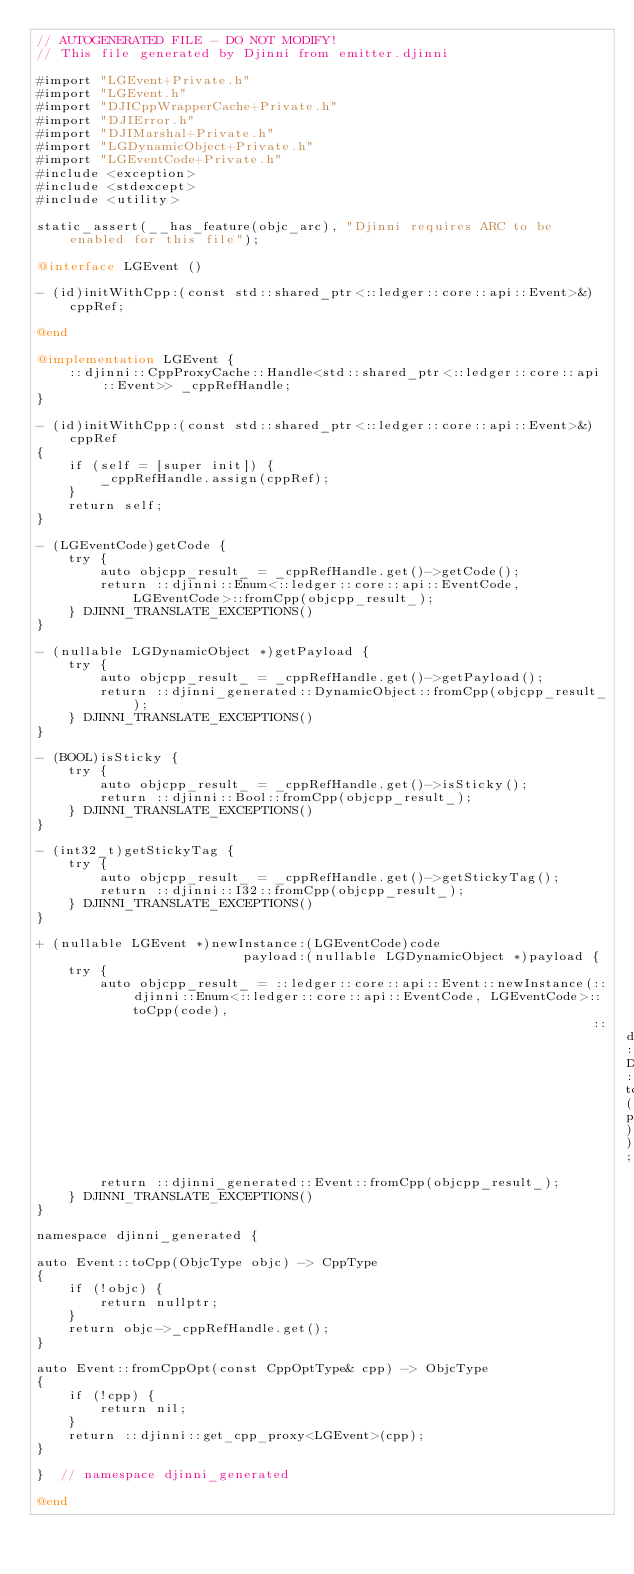Convert code to text. <code><loc_0><loc_0><loc_500><loc_500><_ObjectiveC_>// AUTOGENERATED FILE - DO NOT MODIFY!
// This file generated by Djinni from emitter.djinni

#import "LGEvent+Private.h"
#import "LGEvent.h"
#import "DJICppWrapperCache+Private.h"
#import "DJIError.h"
#import "DJIMarshal+Private.h"
#import "LGDynamicObject+Private.h"
#import "LGEventCode+Private.h"
#include <exception>
#include <stdexcept>
#include <utility>

static_assert(__has_feature(objc_arc), "Djinni requires ARC to be enabled for this file");

@interface LGEvent ()

- (id)initWithCpp:(const std::shared_ptr<::ledger::core::api::Event>&)cppRef;

@end

@implementation LGEvent {
    ::djinni::CppProxyCache::Handle<std::shared_ptr<::ledger::core::api::Event>> _cppRefHandle;
}

- (id)initWithCpp:(const std::shared_ptr<::ledger::core::api::Event>&)cppRef
{
    if (self = [super init]) {
        _cppRefHandle.assign(cppRef);
    }
    return self;
}

- (LGEventCode)getCode {
    try {
        auto objcpp_result_ = _cppRefHandle.get()->getCode();
        return ::djinni::Enum<::ledger::core::api::EventCode, LGEventCode>::fromCpp(objcpp_result_);
    } DJINNI_TRANSLATE_EXCEPTIONS()
}

- (nullable LGDynamicObject *)getPayload {
    try {
        auto objcpp_result_ = _cppRefHandle.get()->getPayload();
        return ::djinni_generated::DynamicObject::fromCpp(objcpp_result_);
    } DJINNI_TRANSLATE_EXCEPTIONS()
}

- (BOOL)isSticky {
    try {
        auto objcpp_result_ = _cppRefHandle.get()->isSticky();
        return ::djinni::Bool::fromCpp(objcpp_result_);
    } DJINNI_TRANSLATE_EXCEPTIONS()
}

- (int32_t)getStickyTag {
    try {
        auto objcpp_result_ = _cppRefHandle.get()->getStickyTag();
        return ::djinni::I32::fromCpp(objcpp_result_);
    } DJINNI_TRANSLATE_EXCEPTIONS()
}

+ (nullable LGEvent *)newInstance:(LGEventCode)code
                          payload:(nullable LGDynamicObject *)payload {
    try {
        auto objcpp_result_ = ::ledger::core::api::Event::newInstance(::djinni::Enum<::ledger::core::api::EventCode, LGEventCode>::toCpp(code),
                                                                      ::djinni_generated::DynamicObject::toCpp(payload));
        return ::djinni_generated::Event::fromCpp(objcpp_result_);
    } DJINNI_TRANSLATE_EXCEPTIONS()
}

namespace djinni_generated {

auto Event::toCpp(ObjcType objc) -> CppType
{
    if (!objc) {
        return nullptr;
    }
    return objc->_cppRefHandle.get();
}

auto Event::fromCppOpt(const CppOptType& cpp) -> ObjcType
{
    if (!cpp) {
        return nil;
    }
    return ::djinni::get_cpp_proxy<LGEvent>(cpp);
}

}  // namespace djinni_generated

@end
</code> 